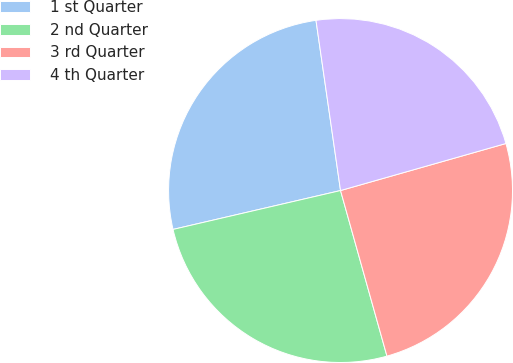<chart> <loc_0><loc_0><loc_500><loc_500><pie_chart><fcel>1 st Quarter<fcel>2 nd Quarter<fcel>3 rd Quarter<fcel>4 th Quarter<nl><fcel>26.35%<fcel>25.72%<fcel>25.06%<fcel>22.87%<nl></chart> 